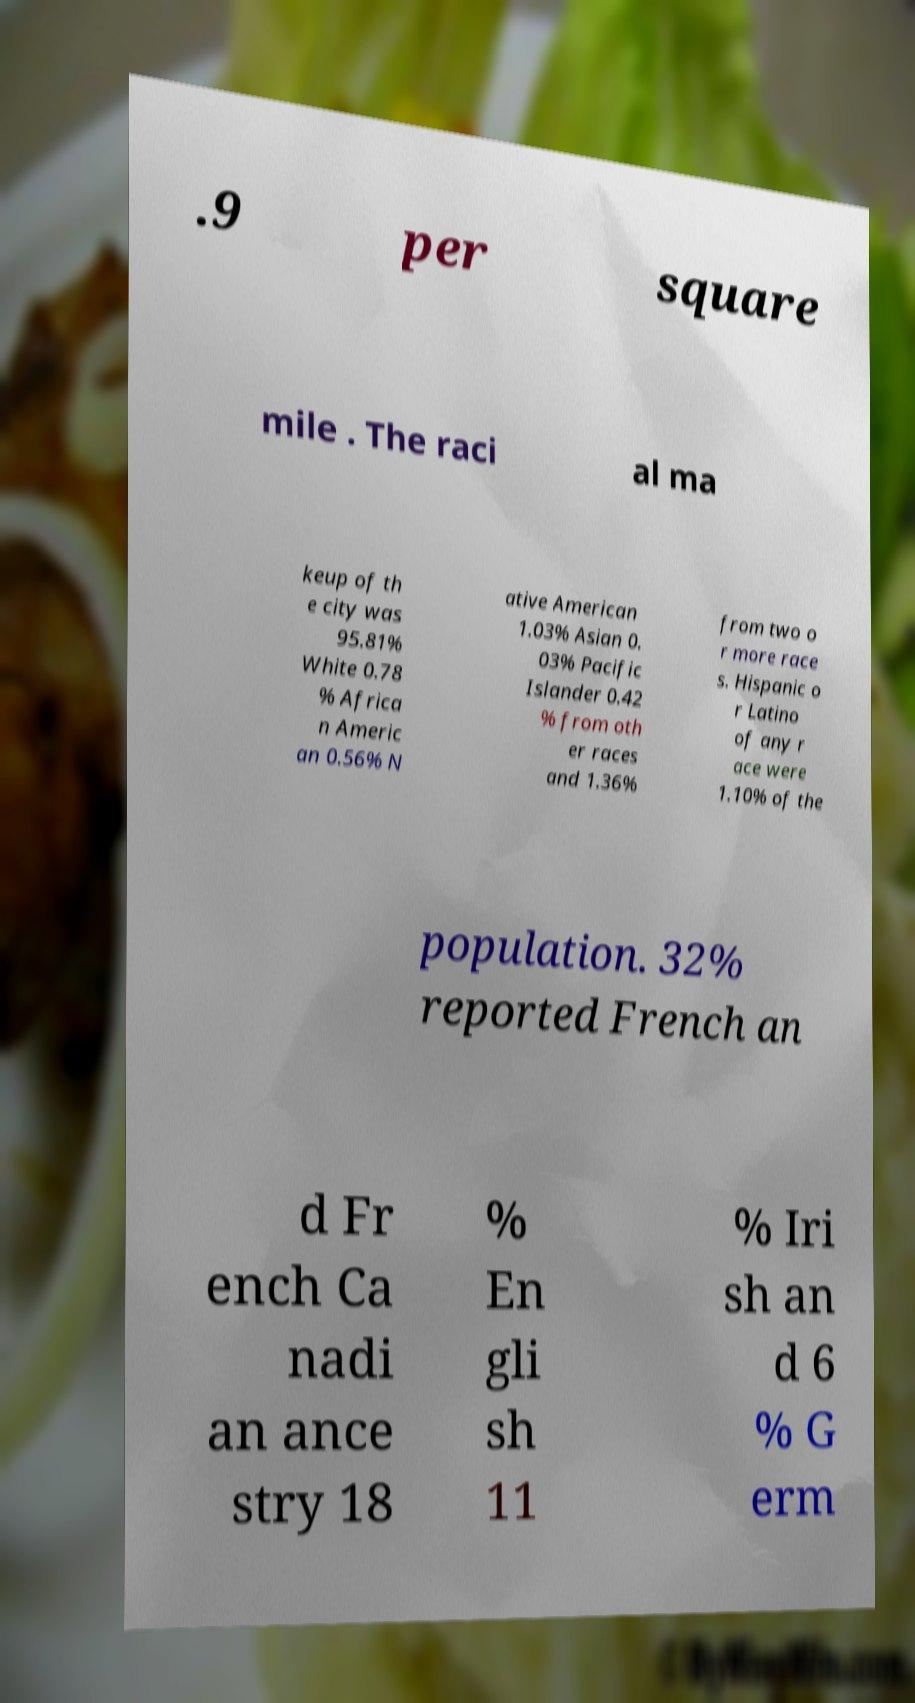Can you accurately transcribe the text from the provided image for me? .9 per square mile . The raci al ma keup of th e city was 95.81% White 0.78 % Africa n Americ an 0.56% N ative American 1.03% Asian 0. 03% Pacific Islander 0.42 % from oth er races and 1.36% from two o r more race s. Hispanic o r Latino of any r ace were 1.10% of the population. 32% reported French an d Fr ench Ca nadi an ance stry 18 % En gli sh 11 % Iri sh an d 6 % G erm 